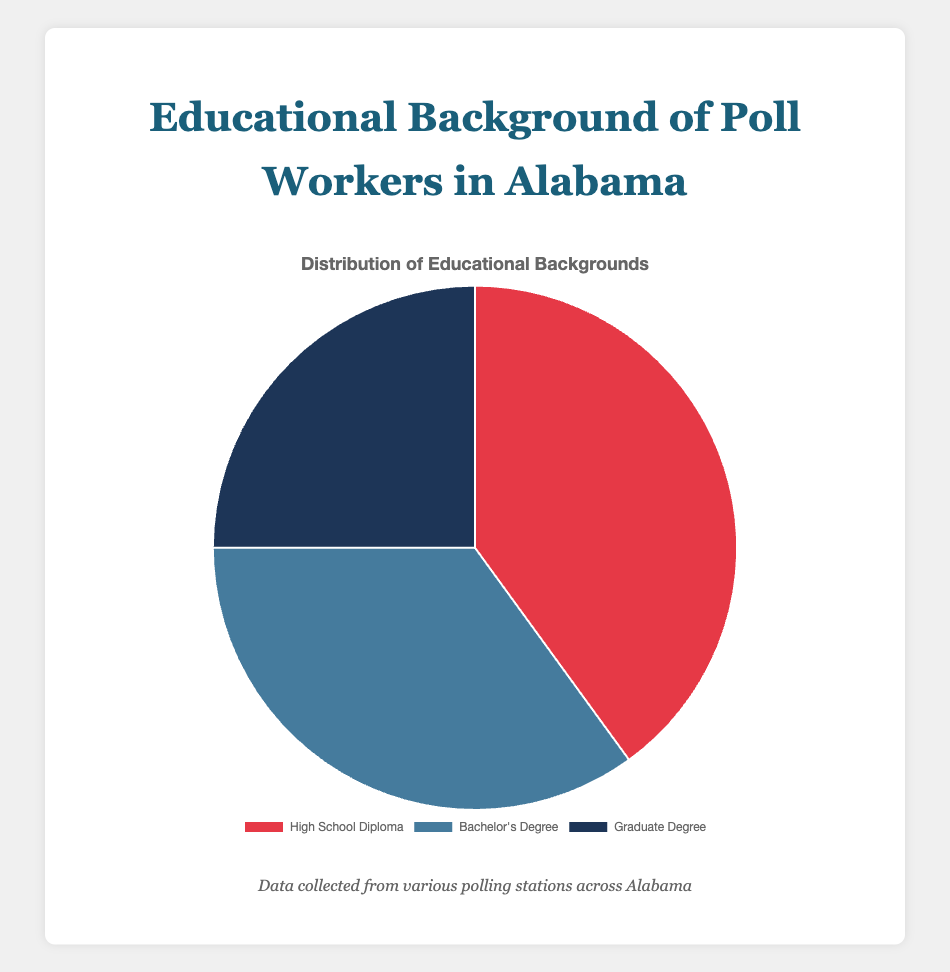What is the percentage of poll workers with a Bachelor's degree? The percentage of poll workers with a Bachelor's degree is directly labeled in the pie chart and is 35%.
Answer: 35% Which educational background has the highest representation among poll workers? The pie chart shows three categories: High School Diploma, Bachelor's Degree, and Graduate Degree. The largest portion is the High School Diploma at 40%.
Answer: High School Diploma By how much does the percentage of poll workers with a High School Diploma exceed that of those with a Graduate Degree? From the pie chart, poll workers with a High School Diploma constitute 40%, while those with a Graduate Degree make up 25%. The difference is 40% - 25% = 15%.
Answer: 15% What is the combined percentage of poll workers with a Bachelor's Degree and a Graduate Degree? Combining the percentages of poll workers with a Bachelor's Degree (35%) and a Graduate Degree (25%) results in 35% + 25% = 60%.
Answer: 60% Which educational background is represented by the smallest portion in the pie chart? The smallest portion on the pie chart is for Graduate Degree holders, which is 25%.
Answer: Graduate Degree How many polling stations contributed data for poll workers with a High School Diploma? The information indicates that data was collected from Birmingham Central, Montgomery Downtown, Mobile Harbor, and Tuscaloosa West, which totals 4 polling stations.
Answer: 4 If you were to remove all poll workers with a Graduate Degree, what percentage of the remaining poll workers would have a High School Diploma? Removing the 25% of poll workers with Graduate Degrees leaves 75%. The remaining percentage is divided into High School Diploma (40%) and Bachelor’s Degree (35%). The proportion of those with a High School Diploma among the remaining poll workers would be (40% / 75%) * 100 ≈ 53.33%.
Answer: 53.33% What color represents the Bachelor's Degree category in the pie chart? The pie chart uses specific colors to represent the categories. The Bachelor's Degree category is represented by blue.
Answer: Blue 